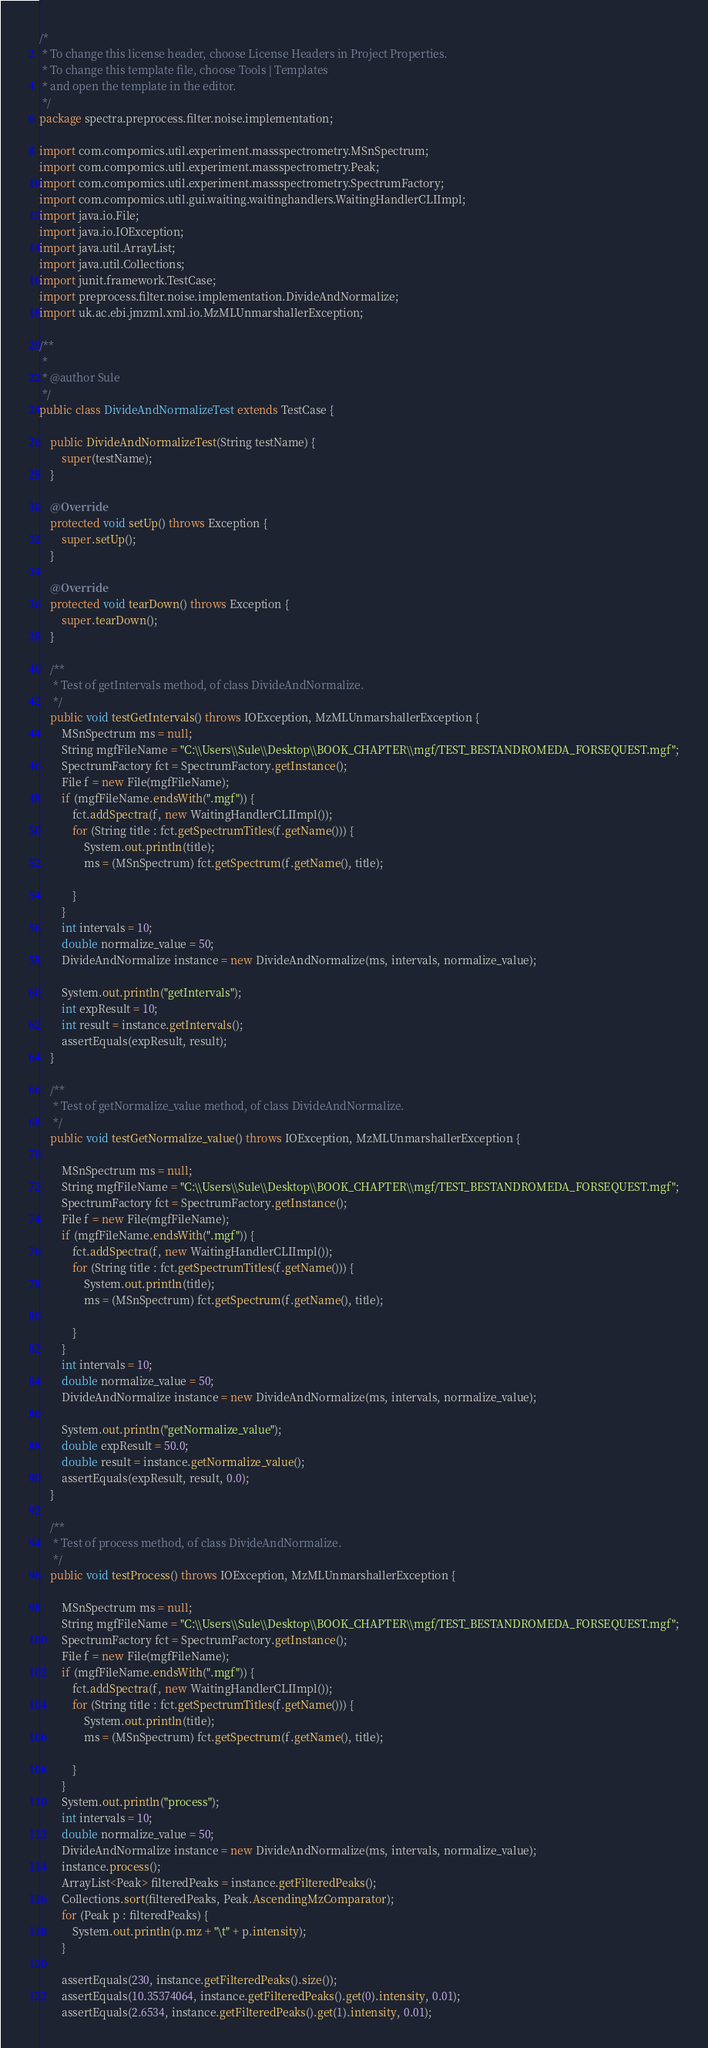<code> <loc_0><loc_0><loc_500><loc_500><_Java_>/*
 * To change this license header, choose License Headers in Project Properties.
 * To change this template file, choose Tools | Templates
 * and open the template in the editor.
 */
package spectra.preprocess.filter.noise.implementation;

import com.compomics.util.experiment.massspectrometry.MSnSpectrum;
import com.compomics.util.experiment.massspectrometry.Peak;
import com.compomics.util.experiment.massspectrometry.SpectrumFactory;
import com.compomics.util.gui.waiting.waitinghandlers.WaitingHandlerCLIImpl;
import java.io.File;
import java.io.IOException;
import java.util.ArrayList;
import java.util.Collections;
import junit.framework.TestCase;
import preprocess.filter.noise.implementation.DivideAndNormalize;
import uk.ac.ebi.jmzml.xml.io.MzMLUnmarshallerException;

/**
 *
 * @author Sule
 */
public class DivideAndNormalizeTest extends TestCase {

    public DivideAndNormalizeTest(String testName) {
        super(testName);
    }

    @Override
    protected void setUp() throws Exception {
        super.setUp();
    }

    @Override
    protected void tearDown() throws Exception {
        super.tearDown();
    }

    /**
     * Test of getIntervals method, of class DivideAndNormalize.
     */
    public void testGetIntervals() throws IOException, MzMLUnmarshallerException {
        MSnSpectrum ms = null;
        String mgfFileName = "C:\\Users\\Sule\\Desktop\\BOOK_CHAPTER\\mgf/TEST_BESTANDROMEDA_FORSEQUEST.mgf";
        SpectrumFactory fct = SpectrumFactory.getInstance();
        File f = new File(mgfFileName);
        if (mgfFileName.endsWith(".mgf")) {
            fct.addSpectra(f, new WaitingHandlerCLIImpl());
            for (String title : fct.getSpectrumTitles(f.getName())) {
                System.out.println(title);
                ms = (MSnSpectrum) fct.getSpectrum(f.getName(), title);

            }
        }
        int intervals = 10;
        double normalize_value = 50;
        DivideAndNormalize instance = new DivideAndNormalize(ms, intervals, normalize_value);

        System.out.println("getIntervals");
        int expResult = 10;
        int result = instance.getIntervals();
        assertEquals(expResult, result);
    }

    /**
     * Test of getNormalize_value method, of class DivideAndNormalize.
     */
    public void testGetNormalize_value() throws IOException, MzMLUnmarshallerException {

        MSnSpectrum ms = null;
        String mgfFileName = "C:\\Users\\Sule\\Desktop\\BOOK_CHAPTER\\mgf/TEST_BESTANDROMEDA_FORSEQUEST.mgf";
        SpectrumFactory fct = SpectrumFactory.getInstance();
        File f = new File(mgfFileName);
        if (mgfFileName.endsWith(".mgf")) {
            fct.addSpectra(f, new WaitingHandlerCLIImpl());
            for (String title : fct.getSpectrumTitles(f.getName())) {
                System.out.println(title);
                ms = (MSnSpectrum) fct.getSpectrum(f.getName(), title);

            }
        }
        int intervals = 10;
        double normalize_value = 50;
        DivideAndNormalize instance = new DivideAndNormalize(ms, intervals, normalize_value);

        System.out.println("getNormalize_value");
        double expResult = 50.0;
        double result = instance.getNormalize_value();
        assertEquals(expResult, result, 0.0);
    }

    /**
     * Test of process method, of class DivideAndNormalize.
     */
    public void testProcess() throws IOException, MzMLUnmarshallerException {

        MSnSpectrum ms = null;
        String mgfFileName = "C:\\Users\\Sule\\Desktop\\BOOK_CHAPTER\\mgf/TEST_BESTANDROMEDA_FORSEQUEST.mgf";
        SpectrumFactory fct = SpectrumFactory.getInstance();
        File f = new File(mgfFileName);
        if (mgfFileName.endsWith(".mgf")) {
            fct.addSpectra(f, new WaitingHandlerCLIImpl());
            for (String title : fct.getSpectrumTitles(f.getName())) {
                System.out.println(title);
                ms = (MSnSpectrum) fct.getSpectrum(f.getName(), title);

            }
        }
        System.out.println("process");
        int intervals = 10;
        double normalize_value = 50;
        DivideAndNormalize instance = new DivideAndNormalize(ms, intervals, normalize_value);
        instance.process();
        ArrayList<Peak> filteredPeaks = instance.getFilteredPeaks();
        Collections.sort(filteredPeaks, Peak.AscendingMzComparator);
        for (Peak p : filteredPeaks) {
            System.out.println(p.mz + "\t" + p.intensity);
        }

        assertEquals(230, instance.getFilteredPeaks().size());
        assertEquals(10.35374064, instance.getFilteredPeaks().get(0).intensity, 0.01);
        assertEquals(2.6534, instance.getFilteredPeaks().get(1).intensity, 0.01);</code> 